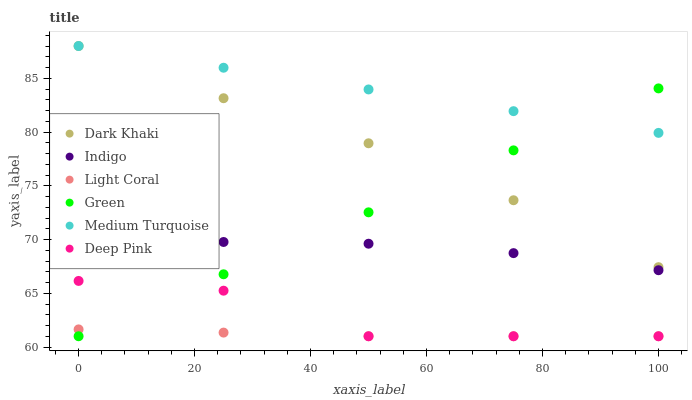Does Light Coral have the minimum area under the curve?
Answer yes or no. Yes. Does Medium Turquoise have the maximum area under the curve?
Answer yes or no. Yes. Does Deep Pink have the minimum area under the curve?
Answer yes or no. No. Does Deep Pink have the maximum area under the curve?
Answer yes or no. No. Is Green the smoothest?
Answer yes or no. Yes. Is Deep Pink the roughest?
Answer yes or no. Yes. Is Indigo the smoothest?
Answer yes or no. No. Is Indigo the roughest?
Answer yes or no. No. Does Light Coral have the lowest value?
Answer yes or no. Yes. Does Indigo have the lowest value?
Answer yes or no. No. Does Medium Turquoise have the highest value?
Answer yes or no. Yes. Does Deep Pink have the highest value?
Answer yes or no. No. Is Indigo less than Medium Turquoise?
Answer yes or no. Yes. Is Dark Khaki greater than Deep Pink?
Answer yes or no. Yes. Does Light Coral intersect Green?
Answer yes or no. Yes. Is Light Coral less than Green?
Answer yes or no. No. Is Light Coral greater than Green?
Answer yes or no. No. Does Indigo intersect Medium Turquoise?
Answer yes or no. No. 